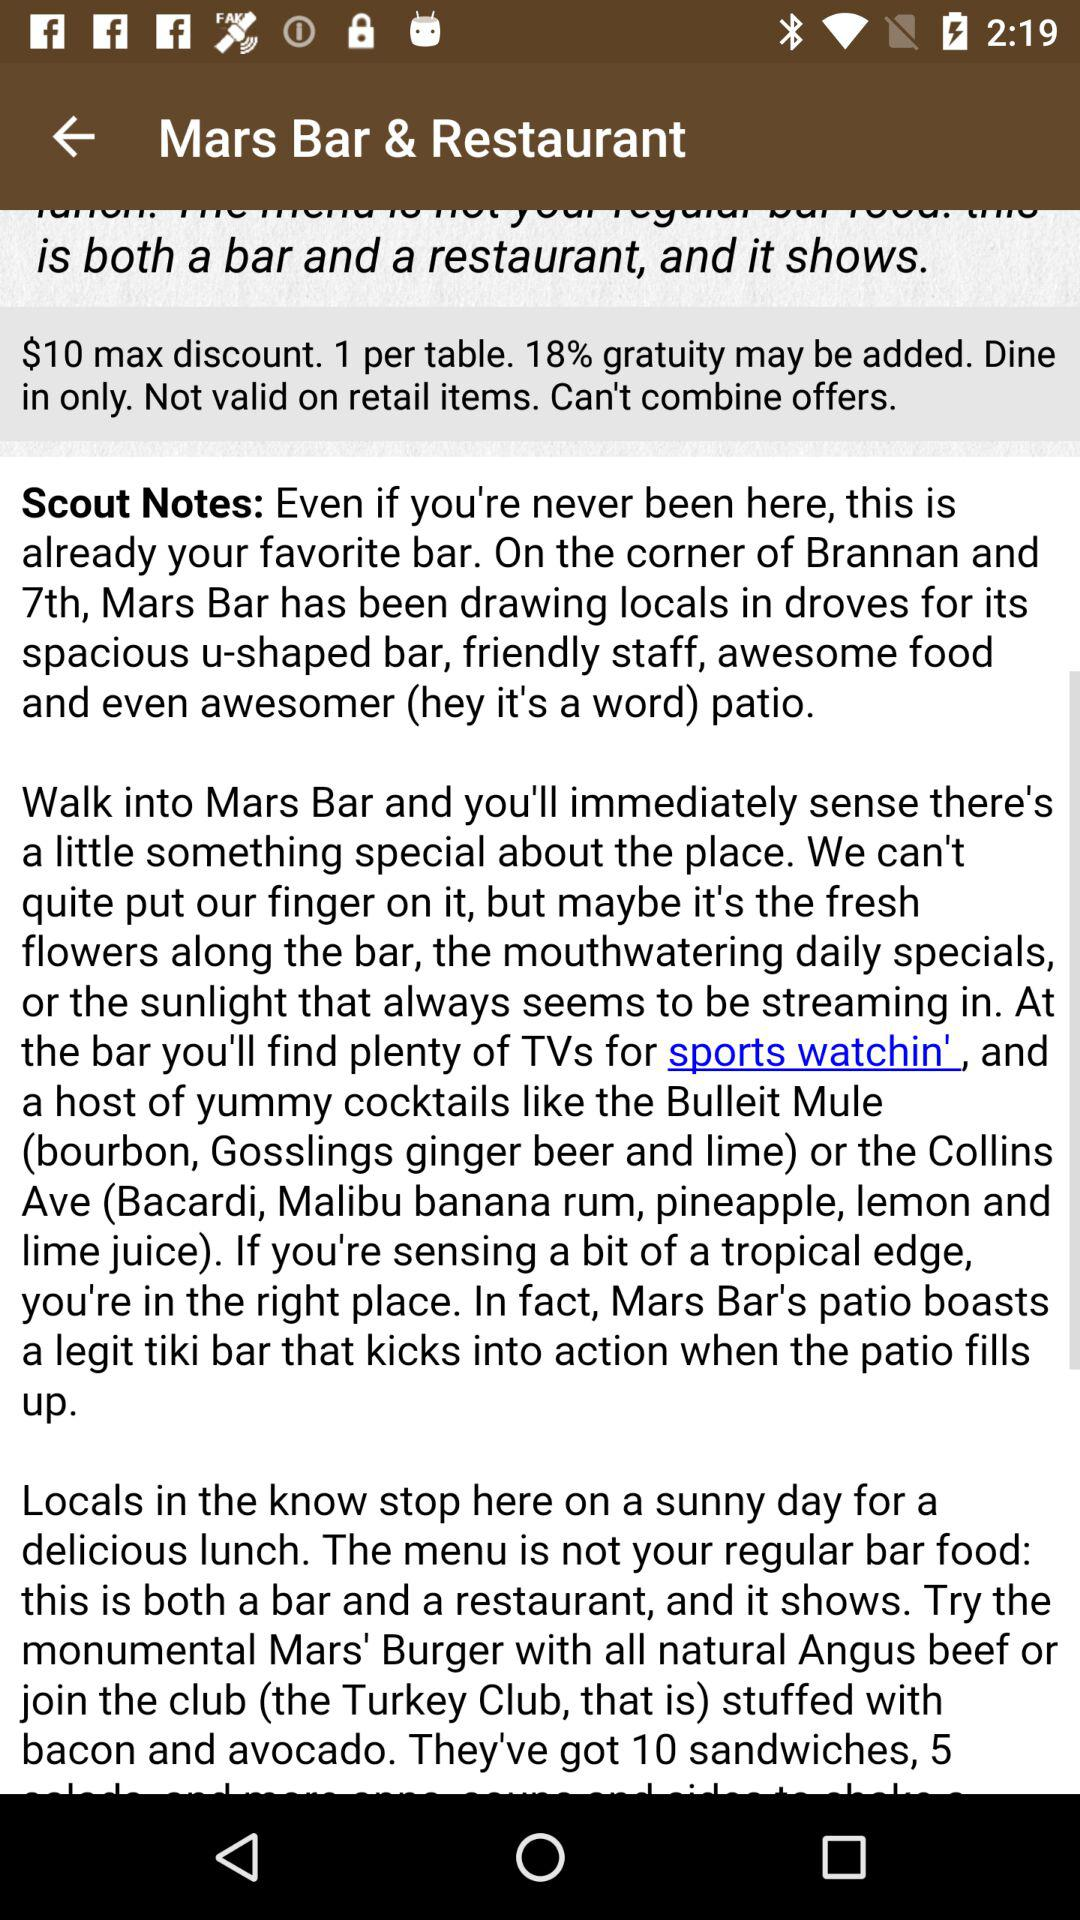What is the geometry of the Mars Bar & Restaurant?
When the provided information is insufficient, respond with <no answer>. <no answer> 